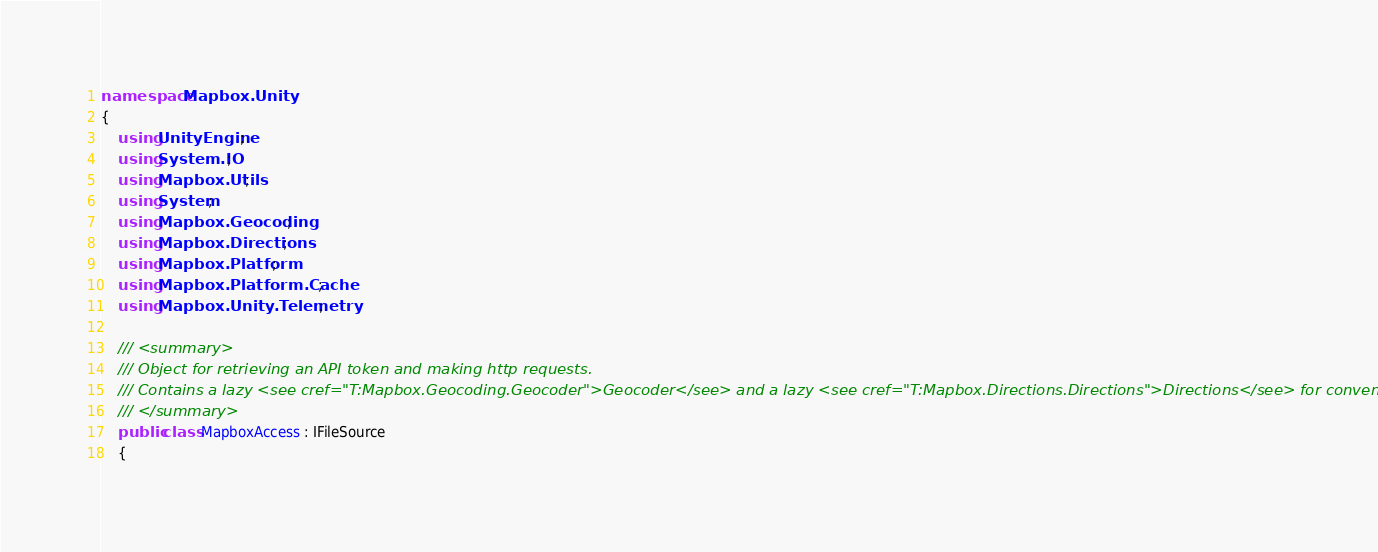Convert code to text. <code><loc_0><loc_0><loc_500><loc_500><_C#_>namespace Mapbox.Unity
{
	using UnityEngine;
	using System.IO;
	using Mapbox.Utils;
	using System;
	using Mapbox.Geocoding;
	using Mapbox.Directions;
	using Mapbox.Platform;
	using Mapbox.Platform.Cache;
	using Mapbox.Unity.Telemetry;

	/// <summary>
	/// Object for retrieving an API token and making http requests.
	/// Contains a lazy <see cref="T:Mapbox.Geocoding.Geocoder">Geocoder</see> and a lazy <see cref="T:Mapbox.Directions.Directions">Directions</see> for convenience.
	/// </summary>
	public class MapboxAccess : IFileSource
	{</code> 